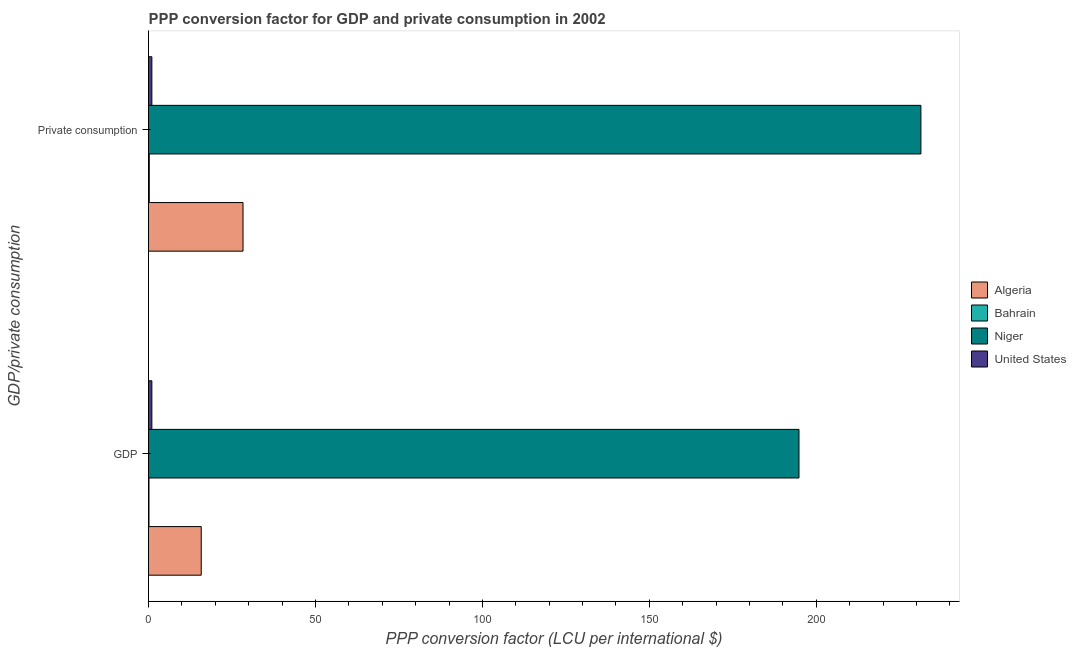How many different coloured bars are there?
Provide a short and direct response. 4. How many bars are there on the 2nd tick from the top?
Make the answer very short. 4. How many bars are there on the 2nd tick from the bottom?
Your response must be concise. 4. What is the label of the 1st group of bars from the top?
Your answer should be compact.  Private consumption. What is the ppp conversion factor for gdp in Bahrain?
Keep it short and to the point. 0.14. Across all countries, what is the maximum ppp conversion factor for gdp?
Provide a succinct answer. 194.83. Across all countries, what is the minimum ppp conversion factor for gdp?
Your answer should be very brief. 0.14. In which country was the ppp conversion factor for gdp maximum?
Give a very brief answer. Niger. In which country was the ppp conversion factor for gdp minimum?
Make the answer very short. Bahrain. What is the total ppp conversion factor for gdp in the graph?
Offer a very short reply. 211.76. What is the difference between the ppp conversion factor for private consumption in Niger and that in United States?
Offer a terse response. 230.35. What is the difference between the ppp conversion factor for gdp in Bahrain and the ppp conversion factor for private consumption in Algeria?
Ensure brevity in your answer.  -28.17. What is the average ppp conversion factor for gdp per country?
Provide a short and direct response. 52.94. What is the difference between the ppp conversion factor for private consumption and ppp conversion factor for gdp in Niger?
Give a very brief answer. 36.51. In how many countries, is the ppp conversion factor for gdp greater than 230 LCU?
Offer a very short reply. 0. What is the ratio of the ppp conversion factor for gdp in United States to that in Bahrain?
Your answer should be very brief. 7.27. Is the ppp conversion factor for gdp in Algeria less than that in Niger?
Your answer should be compact. Yes. What does the 3rd bar from the bottom in GDP represents?
Your answer should be very brief. Niger. How many bars are there?
Your answer should be very brief. 8. Are all the bars in the graph horizontal?
Offer a terse response. Yes. What is the difference between two consecutive major ticks on the X-axis?
Make the answer very short. 50. Are the values on the major ticks of X-axis written in scientific E-notation?
Make the answer very short. No. Does the graph contain any zero values?
Provide a succinct answer. No. How are the legend labels stacked?
Your answer should be very brief. Vertical. What is the title of the graph?
Make the answer very short. PPP conversion factor for GDP and private consumption in 2002. What is the label or title of the X-axis?
Keep it short and to the point. PPP conversion factor (LCU per international $). What is the label or title of the Y-axis?
Ensure brevity in your answer.  GDP/private consumption. What is the PPP conversion factor (LCU per international $) in Algeria in GDP?
Make the answer very short. 15.79. What is the PPP conversion factor (LCU per international $) of Bahrain in GDP?
Provide a succinct answer. 0.14. What is the PPP conversion factor (LCU per international $) in Niger in GDP?
Make the answer very short. 194.83. What is the PPP conversion factor (LCU per international $) of United States in GDP?
Provide a succinct answer. 1. What is the PPP conversion factor (LCU per international $) in Algeria in  Private consumption?
Offer a terse response. 28.3. What is the PPP conversion factor (LCU per international $) of Bahrain in  Private consumption?
Make the answer very short. 0.22. What is the PPP conversion factor (LCU per international $) in Niger in  Private consumption?
Give a very brief answer. 231.35. What is the PPP conversion factor (LCU per international $) in United States in  Private consumption?
Offer a very short reply. 1. Across all GDP/private consumption, what is the maximum PPP conversion factor (LCU per international $) in Algeria?
Your response must be concise. 28.3. Across all GDP/private consumption, what is the maximum PPP conversion factor (LCU per international $) of Bahrain?
Make the answer very short. 0.22. Across all GDP/private consumption, what is the maximum PPP conversion factor (LCU per international $) of Niger?
Your response must be concise. 231.35. Across all GDP/private consumption, what is the minimum PPP conversion factor (LCU per international $) of Algeria?
Provide a succinct answer. 15.79. Across all GDP/private consumption, what is the minimum PPP conversion factor (LCU per international $) of Bahrain?
Ensure brevity in your answer.  0.14. Across all GDP/private consumption, what is the minimum PPP conversion factor (LCU per international $) of Niger?
Make the answer very short. 194.83. Across all GDP/private consumption, what is the minimum PPP conversion factor (LCU per international $) of United States?
Give a very brief answer. 1. What is the total PPP conversion factor (LCU per international $) in Algeria in the graph?
Make the answer very short. 44.09. What is the total PPP conversion factor (LCU per international $) of Bahrain in the graph?
Provide a succinct answer. 0.36. What is the total PPP conversion factor (LCU per international $) in Niger in the graph?
Ensure brevity in your answer.  426.18. What is the total PPP conversion factor (LCU per international $) in United States in the graph?
Keep it short and to the point. 2. What is the difference between the PPP conversion factor (LCU per international $) of Algeria in GDP and that in  Private consumption?
Provide a short and direct response. -12.52. What is the difference between the PPP conversion factor (LCU per international $) of Bahrain in GDP and that in  Private consumption?
Offer a very short reply. -0.08. What is the difference between the PPP conversion factor (LCU per international $) in Niger in GDP and that in  Private consumption?
Offer a terse response. -36.51. What is the difference between the PPP conversion factor (LCU per international $) in Algeria in GDP and the PPP conversion factor (LCU per international $) in Bahrain in  Private consumption?
Ensure brevity in your answer.  15.57. What is the difference between the PPP conversion factor (LCU per international $) of Algeria in GDP and the PPP conversion factor (LCU per international $) of Niger in  Private consumption?
Offer a terse response. -215.56. What is the difference between the PPP conversion factor (LCU per international $) in Algeria in GDP and the PPP conversion factor (LCU per international $) in United States in  Private consumption?
Provide a short and direct response. 14.79. What is the difference between the PPP conversion factor (LCU per international $) of Bahrain in GDP and the PPP conversion factor (LCU per international $) of Niger in  Private consumption?
Ensure brevity in your answer.  -231.21. What is the difference between the PPP conversion factor (LCU per international $) in Bahrain in GDP and the PPP conversion factor (LCU per international $) in United States in  Private consumption?
Provide a succinct answer. -0.86. What is the difference between the PPP conversion factor (LCU per international $) in Niger in GDP and the PPP conversion factor (LCU per international $) in United States in  Private consumption?
Your answer should be compact. 193.83. What is the average PPP conversion factor (LCU per international $) of Algeria per GDP/private consumption?
Ensure brevity in your answer.  22.05. What is the average PPP conversion factor (LCU per international $) of Bahrain per GDP/private consumption?
Offer a terse response. 0.18. What is the average PPP conversion factor (LCU per international $) of Niger per GDP/private consumption?
Make the answer very short. 213.09. What is the average PPP conversion factor (LCU per international $) in United States per GDP/private consumption?
Give a very brief answer. 1. What is the difference between the PPP conversion factor (LCU per international $) of Algeria and PPP conversion factor (LCU per international $) of Bahrain in GDP?
Give a very brief answer. 15.65. What is the difference between the PPP conversion factor (LCU per international $) of Algeria and PPP conversion factor (LCU per international $) of Niger in GDP?
Give a very brief answer. -179.04. What is the difference between the PPP conversion factor (LCU per international $) of Algeria and PPP conversion factor (LCU per international $) of United States in GDP?
Provide a short and direct response. 14.79. What is the difference between the PPP conversion factor (LCU per international $) in Bahrain and PPP conversion factor (LCU per international $) in Niger in GDP?
Give a very brief answer. -194.69. What is the difference between the PPP conversion factor (LCU per international $) in Bahrain and PPP conversion factor (LCU per international $) in United States in GDP?
Give a very brief answer. -0.86. What is the difference between the PPP conversion factor (LCU per international $) of Niger and PPP conversion factor (LCU per international $) of United States in GDP?
Make the answer very short. 193.83. What is the difference between the PPP conversion factor (LCU per international $) of Algeria and PPP conversion factor (LCU per international $) of Bahrain in  Private consumption?
Ensure brevity in your answer.  28.08. What is the difference between the PPP conversion factor (LCU per international $) in Algeria and PPP conversion factor (LCU per international $) in Niger in  Private consumption?
Give a very brief answer. -203.04. What is the difference between the PPP conversion factor (LCU per international $) of Algeria and PPP conversion factor (LCU per international $) of United States in  Private consumption?
Provide a short and direct response. 27.3. What is the difference between the PPP conversion factor (LCU per international $) of Bahrain and PPP conversion factor (LCU per international $) of Niger in  Private consumption?
Ensure brevity in your answer.  -231.12. What is the difference between the PPP conversion factor (LCU per international $) of Bahrain and PPP conversion factor (LCU per international $) of United States in  Private consumption?
Your answer should be very brief. -0.78. What is the difference between the PPP conversion factor (LCU per international $) in Niger and PPP conversion factor (LCU per international $) in United States in  Private consumption?
Keep it short and to the point. 230.35. What is the ratio of the PPP conversion factor (LCU per international $) in Algeria in GDP to that in  Private consumption?
Your answer should be compact. 0.56. What is the ratio of the PPP conversion factor (LCU per international $) of Bahrain in GDP to that in  Private consumption?
Offer a terse response. 0.62. What is the ratio of the PPP conversion factor (LCU per international $) in Niger in GDP to that in  Private consumption?
Keep it short and to the point. 0.84. What is the ratio of the PPP conversion factor (LCU per international $) in United States in GDP to that in  Private consumption?
Your response must be concise. 1. What is the difference between the highest and the second highest PPP conversion factor (LCU per international $) of Algeria?
Your answer should be compact. 12.52. What is the difference between the highest and the second highest PPP conversion factor (LCU per international $) of Bahrain?
Provide a succinct answer. 0.08. What is the difference between the highest and the second highest PPP conversion factor (LCU per international $) of Niger?
Make the answer very short. 36.51. What is the difference between the highest and the second highest PPP conversion factor (LCU per international $) in United States?
Ensure brevity in your answer.  0. What is the difference between the highest and the lowest PPP conversion factor (LCU per international $) in Algeria?
Your response must be concise. 12.52. What is the difference between the highest and the lowest PPP conversion factor (LCU per international $) in Bahrain?
Provide a short and direct response. 0.08. What is the difference between the highest and the lowest PPP conversion factor (LCU per international $) of Niger?
Provide a short and direct response. 36.51. What is the difference between the highest and the lowest PPP conversion factor (LCU per international $) of United States?
Keep it short and to the point. 0. 